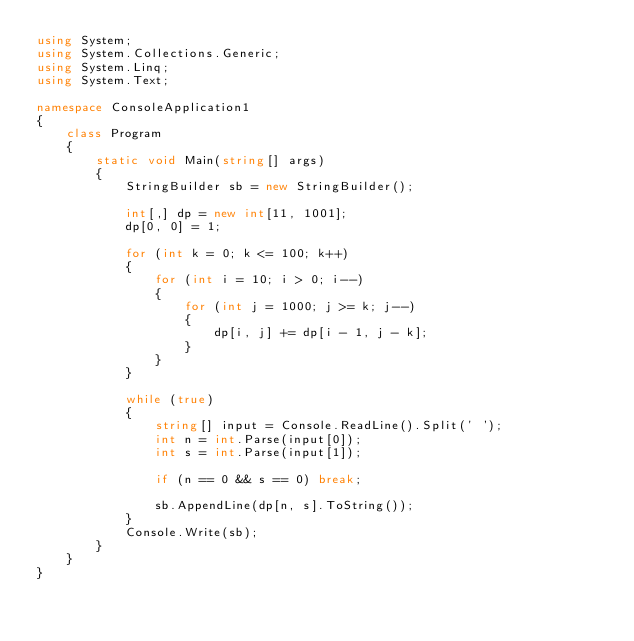<code> <loc_0><loc_0><loc_500><loc_500><_C#_>using System;
using System.Collections.Generic;
using System.Linq;
using System.Text;

namespace ConsoleApplication1
{
    class Program
    {
        static void Main(string[] args)
        {
            StringBuilder sb = new StringBuilder();

            int[,] dp = new int[11, 1001];
            dp[0, 0] = 1;

            for (int k = 0; k <= 100; k++)
            {
                for (int i = 10; i > 0; i--)
                {
                    for (int j = 1000; j >= k; j--)
                    {
                        dp[i, j] += dp[i - 1, j - k];
                    }
                }
            }

            while (true)
            {
                string[] input = Console.ReadLine().Split(' ');
                int n = int.Parse(input[0]);
                int s = int.Parse(input[1]);

                if (n == 0 && s == 0) break;

                sb.AppendLine(dp[n, s].ToString());
            }
            Console.Write(sb);
        }
    }
}</code> 